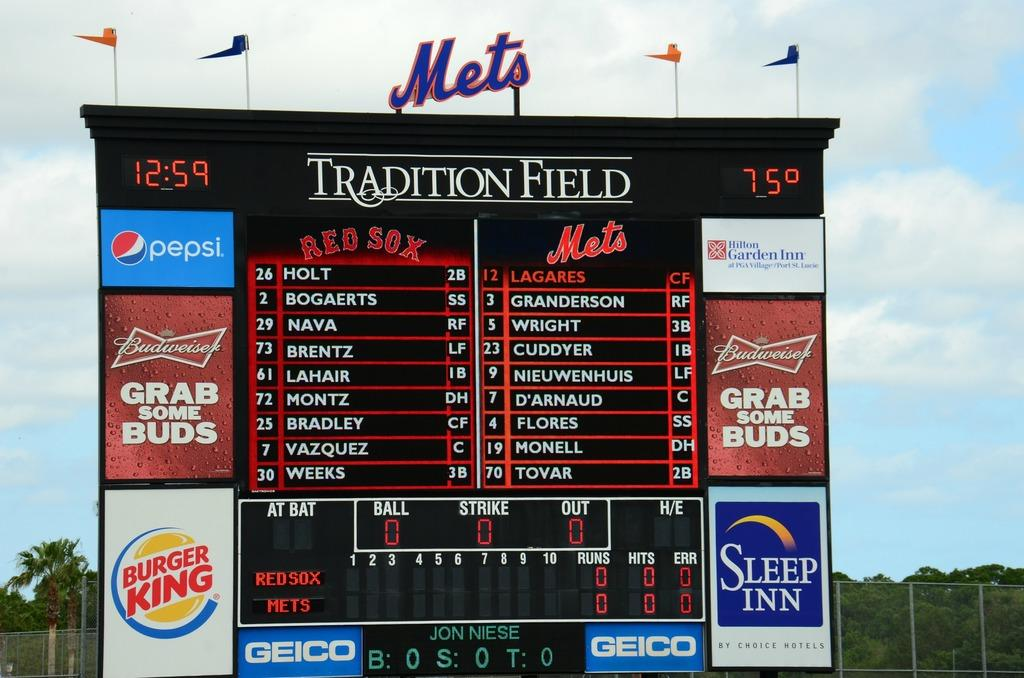<image>
Relay a brief, clear account of the picture shown. A scoreboard for the Red Sox playing the Mets at Tradition Field. 